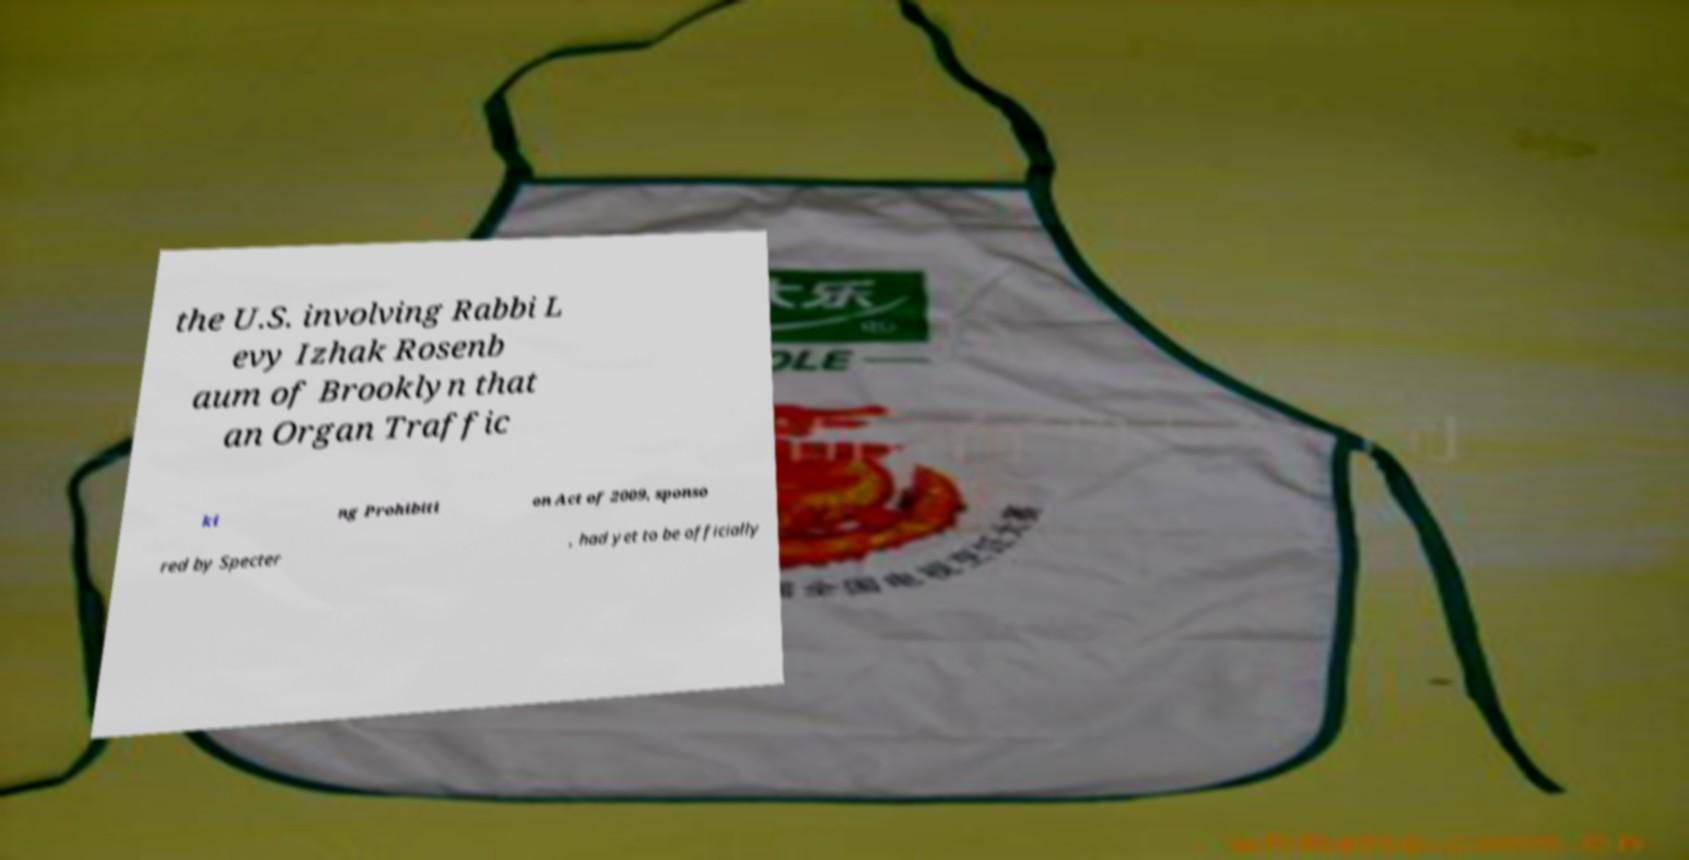Please identify and transcribe the text found in this image. the U.S. involving Rabbi L evy Izhak Rosenb aum of Brooklyn that an Organ Traffic ki ng Prohibiti on Act of 2009, sponso red by Specter , had yet to be officially 